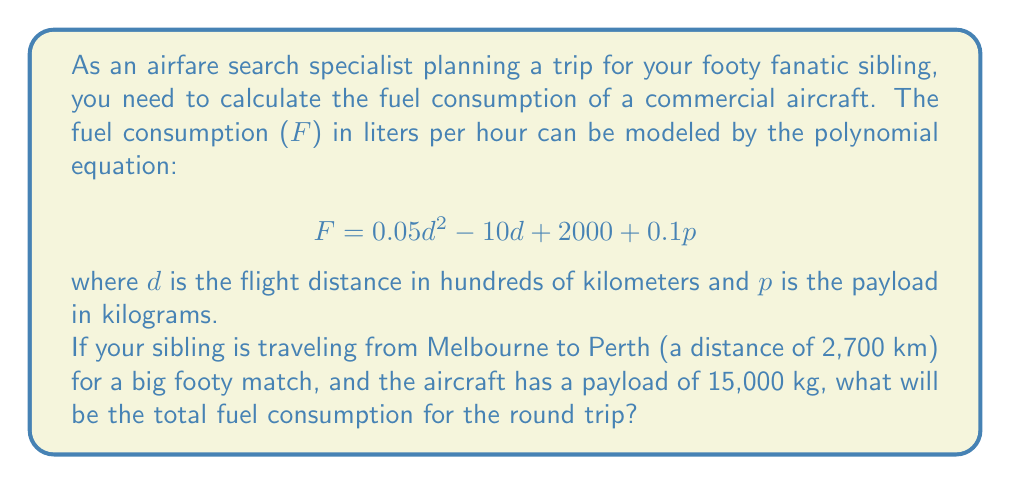Give your solution to this math problem. Let's approach this problem step-by-step:

1) First, we need to convert the distance to hundreds of kilometers:
   2,700 km = 27 hundreds of km

2) Now, let's plug in the values into our equation:
   $d = 27$ (for one way)
   $p = 15000$

3) Let's calculate the fuel consumption for one way:
   $$F = 0.05(27)^2 - 10(27) + 2000 + 0.1(15000)$$

4) Simplify:
   $$F = 0.05(729) - 270 + 2000 + 1500$$
   $$F = 36.45 - 270 + 2000 + 1500$$
   $$F = 3266.45$$ liters per hour

5) To find the total consumption, we need to multiply this by the flight time. The flight time can be estimated by dividing the distance by the average speed of a commercial aircraft (about 900 km/h):

   Flight time = 2700 km ÷ 900 km/h = 3 hours

6) So, the fuel consumption for one way is:
   3266.45 × 3 = 9799.35 liters

7) For a round trip, we double this:
   9799.35 × 2 = 19598.7 liters

Therefore, the total fuel consumption for the round trip will be approximately 19,599 liters.
Answer: 19,599 liters 